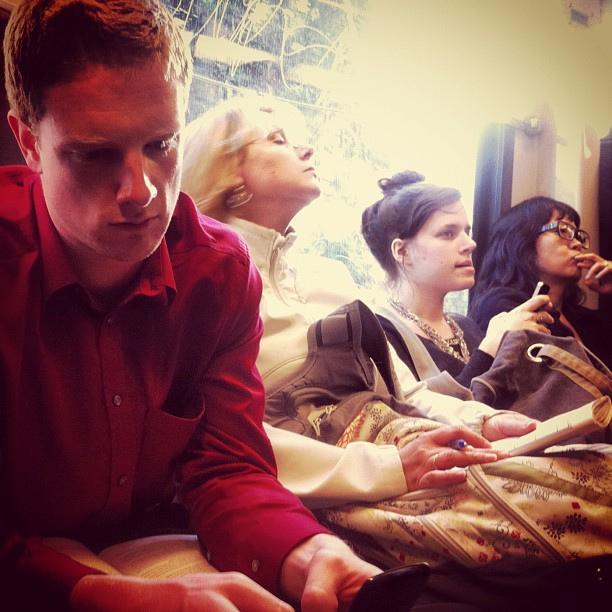Is the man talking to any of the women?
Answer briefly. No. Is the man looking at his phone?
Write a very short answer. Yes. Does the man have a button shirt?
Answer briefly. Yes. 